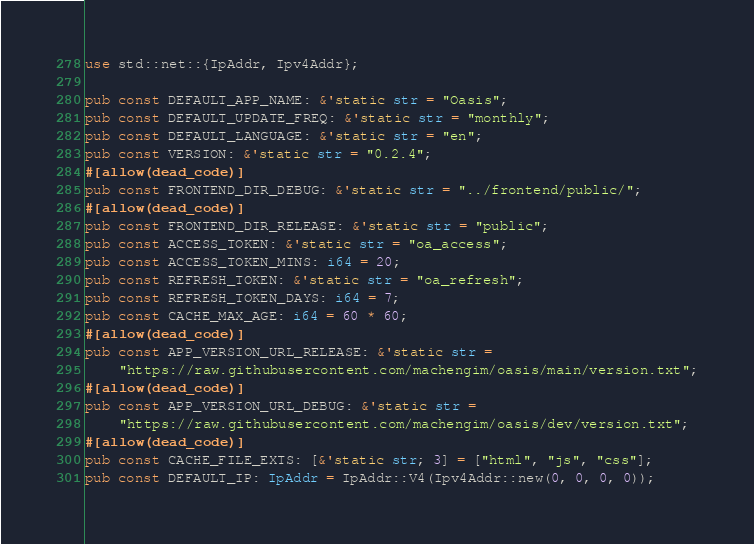Convert code to text. <code><loc_0><loc_0><loc_500><loc_500><_Rust_>use std::net::{IpAddr, Ipv4Addr};

pub const DEFAULT_APP_NAME: &'static str = "Oasis";
pub const DEFAULT_UPDATE_FREQ: &'static str = "monthly";
pub const DEFAULT_LANGUAGE: &'static str = "en";
pub const VERSION: &'static str = "0.2.4";
#[allow(dead_code)]
pub const FRONTEND_DIR_DEBUG: &'static str = "../frontend/public/";
#[allow(dead_code)]
pub const FRONTEND_DIR_RELEASE: &'static str = "public";
pub const ACCESS_TOKEN: &'static str = "oa_access";
pub const ACCESS_TOKEN_MINS: i64 = 20;
pub const REFRESH_TOKEN: &'static str = "oa_refresh";
pub const REFRESH_TOKEN_DAYS: i64 = 7;
pub const CACHE_MAX_AGE: i64 = 60 * 60;
#[allow(dead_code)]
pub const APP_VERSION_URL_RELEASE: &'static str =
    "https://raw.githubusercontent.com/machengim/oasis/main/version.txt";
#[allow(dead_code)]
pub const APP_VERSION_URL_DEBUG: &'static str =
    "https://raw.githubusercontent.com/machengim/oasis/dev/version.txt";
#[allow(dead_code)]
pub const CACHE_FILE_EXTS: [&'static str; 3] = ["html", "js", "css"];
pub const DEFAULT_IP: IpAddr = IpAddr::V4(Ipv4Addr::new(0, 0, 0, 0));
</code> 